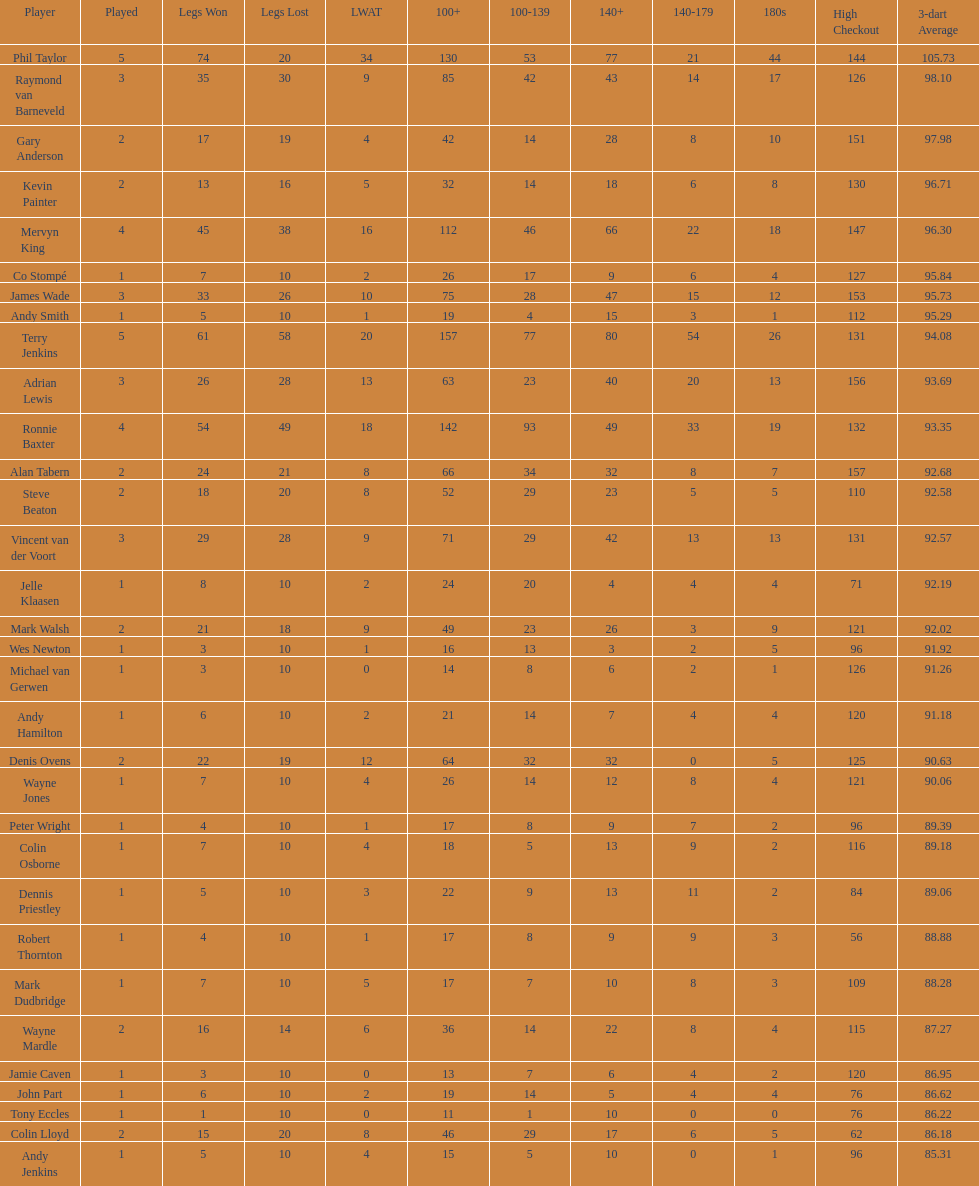Is mark walsh's average higher/lower than 93? Below. 